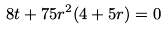Convert formula to latex. <formula><loc_0><loc_0><loc_500><loc_500>8 t + 7 5 r ^ { 2 } ( 4 + 5 r ) = 0</formula> 